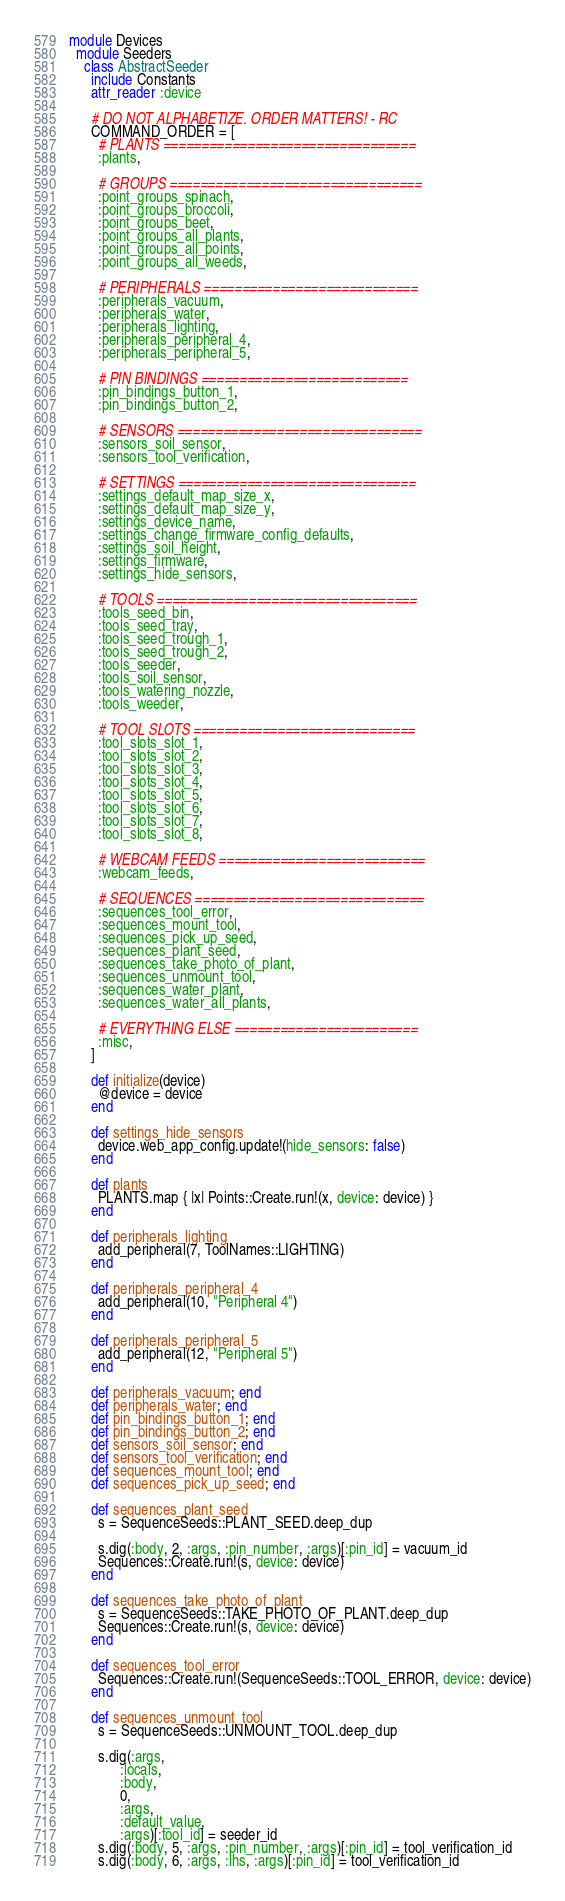<code> <loc_0><loc_0><loc_500><loc_500><_Ruby_>module Devices
  module Seeders
    class AbstractSeeder
      include Constants
      attr_reader :device

      # DO NOT ALPHABETIZE. ORDER MATTERS! - RC
      COMMAND_ORDER = [
        # PLANTS =================================
        :plants,

        # GROUPS =================================
        :point_groups_spinach,
        :point_groups_broccoli,
        :point_groups_beet,
        :point_groups_all_plants,
        :point_groups_all_points,
        :point_groups_all_weeds,

        # PERIPHERALS ============================
        :peripherals_vacuum,
        :peripherals_water,
        :peripherals_lighting,
        :peripherals_peripheral_4,
        :peripherals_peripheral_5,

        # PIN BINDINGS ===========================
        :pin_bindings_button_1,
        :pin_bindings_button_2,

        # SENSORS ================================
        :sensors_soil_sensor,
        :sensors_tool_verification,

        # SETTINGS ===============================
        :settings_default_map_size_x,
        :settings_default_map_size_y,
        :settings_device_name,
        :settings_change_firmware_config_defaults,
        :settings_soil_height,
        :settings_firmware,
        :settings_hide_sensors,

        # TOOLS ==================================
        :tools_seed_bin,
        :tools_seed_tray,
        :tools_seed_trough_1,
        :tools_seed_trough_2,
        :tools_seeder,
        :tools_soil_sensor,
        :tools_watering_nozzle,
        :tools_weeder,

        # TOOL SLOTS =============================
        :tool_slots_slot_1,
        :tool_slots_slot_2,
        :tool_slots_slot_3,
        :tool_slots_slot_4,
        :tool_slots_slot_5,
        :tool_slots_slot_6,
        :tool_slots_slot_7,
        :tool_slots_slot_8,

        # WEBCAM FEEDS ===========================
        :webcam_feeds,

        # SEQUENCES ==============================
        :sequences_tool_error,
        :sequences_mount_tool,
        :sequences_pick_up_seed,
        :sequences_plant_seed,
        :sequences_take_photo_of_plant,
        :sequences_unmount_tool,
        :sequences_water_plant,
        :sequences_water_all_plants,

        # EVERYTHING ELSE ========================
        :misc,
      ]

      def initialize(device)
        @device = device
      end

      def settings_hide_sensors
        device.web_app_config.update!(hide_sensors: false)
      end

      def plants
        PLANTS.map { |x| Points::Create.run!(x, device: device) }
      end

      def peripherals_lighting
        add_peripheral(7, ToolNames::LIGHTING)
      end

      def peripherals_peripheral_4
        add_peripheral(10, "Peripheral 4")
      end

      def peripherals_peripheral_5
        add_peripheral(12, "Peripheral 5")
      end

      def peripherals_vacuum; end
      def peripherals_water; end
      def pin_bindings_button_1; end
      def pin_bindings_button_2; end
      def sensors_soil_sensor; end
      def sensors_tool_verification; end
      def sequences_mount_tool; end
      def sequences_pick_up_seed; end

      def sequences_plant_seed
        s = SequenceSeeds::PLANT_SEED.deep_dup

        s.dig(:body, 2, :args, :pin_number, :args)[:pin_id] = vacuum_id
        Sequences::Create.run!(s, device: device)
      end

      def sequences_take_photo_of_plant
        s = SequenceSeeds::TAKE_PHOTO_OF_PLANT.deep_dup
        Sequences::Create.run!(s, device: device)
      end

      def sequences_tool_error
        Sequences::Create.run!(SequenceSeeds::TOOL_ERROR, device: device)
      end

      def sequences_unmount_tool
        s = SequenceSeeds::UNMOUNT_TOOL.deep_dup

        s.dig(:args,
              :locals,
              :body,
              0,
              :args,
              :default_value,
              :args)[:tool_id] = seeder_id
        s.dig(:body, 5, :args, :pin_number, :args)[:pin_id] = tool_verification_id
        s.dig(:body, 6, :args, :lhs, :args)[:pin_id] = tool_verification_id</code> 